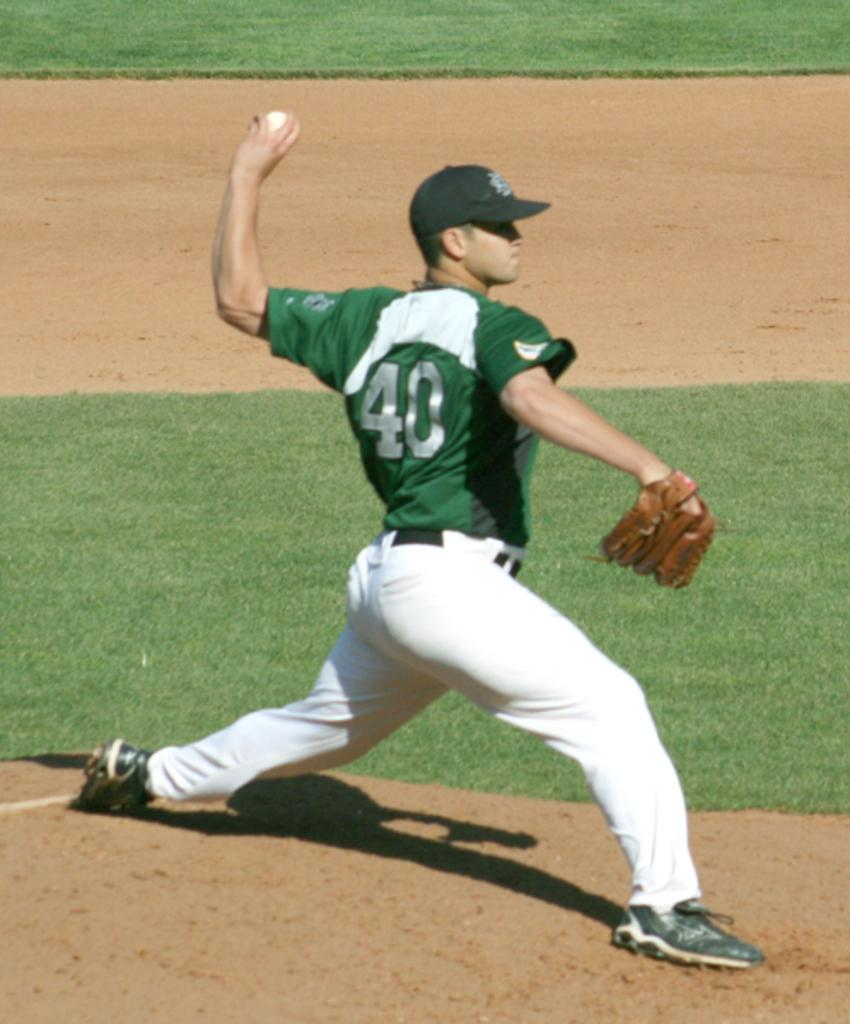<image>
Describe the image concisely. A pitcher wearing a green number 40 jersey and white pants is about to throw a baseball with his left hand. 